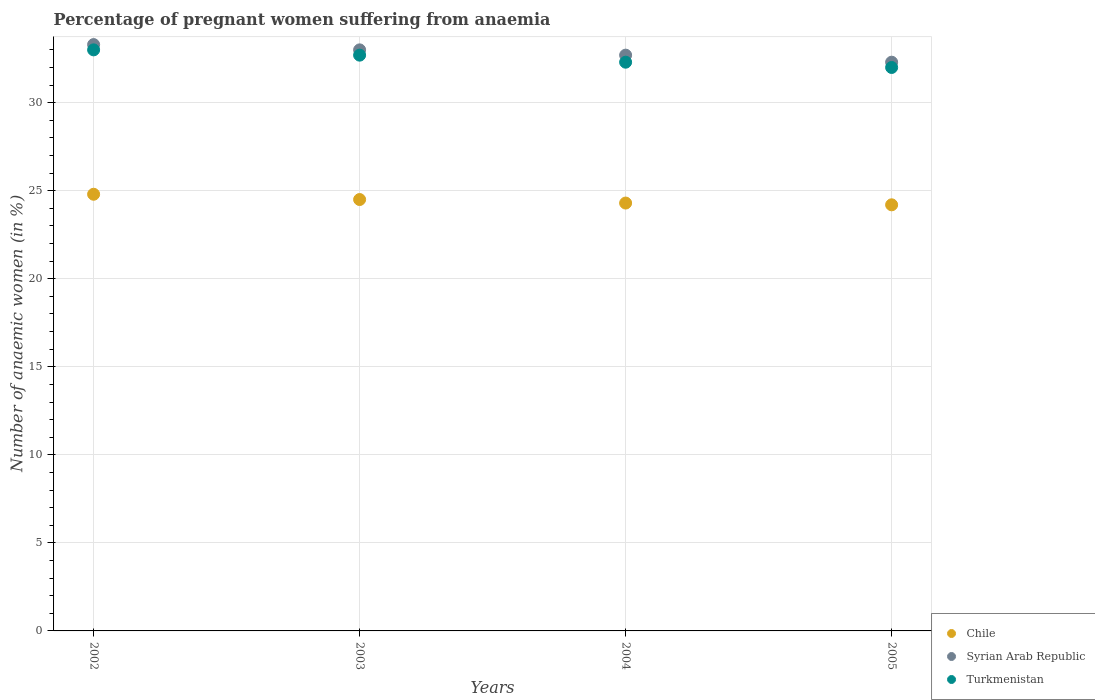What is the number of anaemic women in Turkmenistan in 2002?
Keep it short and to the point. 33. Across all years, what is the maximum number of anaemic women in Chile?
Keep it short and to the point. 24.8. Across all years, what is the minimum number of anaemic women in Syrian Arab Republic?
Provide a succinct answer. 32.3. In which year was the number of anaemic women in Chile maximum?
Provide a succinct answer. 2002. What is the total number of anaemic women in Syrian Arab Republic in the graph?
Provide a short and direct response. 131.3. What is the difference between the number of anaemic women in Chile in 2004 and that in 2005?
Keep it short and to the point. 0.1. What is the difference between the number of anaemic women in Turkmenistan in 2004 and the number of anaemic women in Chile in 2002?
Make the answer very short. 7.5. What is the average number of anaemic women in Turkmenistan per year?
Offer a very short reply. 32.5. In the year 2005, what is the difference between the number of anaemic women in Chile and number of anaemic women in Turkmenistan?
Offer a terse response. -7.8. In how many years, is the number of anaemic women in Chile greater than 27 %?
Provide a short and direct response. 0. What is the ratio of the number of anaemic women in Turkmenistan in 2002 to that in 2005?
Your answer should be compact. 1.03. Is the number of anaemic women in Chile in 2003 less than that in 2005?
Offer a terse response. No. Is the difference between the number of anaemic women in Chile in 2002 and 2004 greater than the difference between the number of anaemic women in Turkmenistan in 2002 and 2004?
Offer a terse response. No. What is the difference between the highest and the second highest number of anaemic women in Chile?
Your response must be concise. 0.3. Is the sum of the number of anaemic women in Turkmenistan in 2002 and 2003 greater than the maximum number of anaemic women in Syrian Arab Republic across all years?
Ensure brevity in your answer.  Yes. Does the number of anaemic women in Chile monotonically increase over the years?
Your response must be concise. No. How many years are there in the graph?
Make the answer very short. 4. Where does the legend appear in the graph?
Offer a very short reply. Bottom right. How are the legend labels stacked?
Ensure brevity in your answer.  Vertical. What is the title of the graph?
Give a very brief answer. Percentage of pregnant women suffering from anaemia. What is the label or title of the Y-axis?
Your response must be concise. Number of anaemic women (in %). What is the Number of anaemic women (in %) in Chile in 2002?
Your answer should be compact. 24.8. What is the Number of anaemic women (in %) in Syrian Arab Republic in 2002?
Your answer should be compact. 33.3. What is the Number of anaemic women (in %) of Turkmenistan in 2002?
Your response must be concise. 33. What is the Number of anaemic women (in %) in Syrian Arab Republic in 2003?
Make the answer very short. 33. What is the Number of anaemic women (in %) of Turkmenistan in 2003?
Keep it short and to the point. 32.7. What is the Number of anaemic women (in %) in Chile in 2004?
Your answer should be compact. 24.3. What is the Number of anaemic women (in %) in Syrian Arab Republic in 2004?
Keep it short and to the point. 32.7. What is the Number of anaemic women (in %) in Turkmenistan in 2004?
Your response must be concise. 32.3. What is the Number of anaemic women (in %) in Chile in 2005?
Offer a very short reply. 24.2. What is the Number of anaemic women (in %) of Syrian Arab Republic in 2005?
Offer a terse response. 32.3. What is the Number of anaemic women (in %) in Turkmenistan in 2005?
Provide a short and direct response. 32. Across all years, what is the maximum Number of anaemic women (in %) of Chile?
Keep it short and to the point. 24.8. Across all years, what is the maximum Number of anaemic women (in %) of Syrian Arab Republic?
Offer a terse response. 33.3. Across all years, what is the minimum Number of anaemic women (in %) in Chile?
Offer a terse response. 24.2. Across all years, what is the minimum Number of anaemic women (in %) of Syrian Arab Republic?
Make the answer very short. 32.3. What is the total Number of anaemic women (in %) in Chile in the graph?
Provide a succinct answer. 97.8. What is the total Number of anaemic women (in %) in Syrian Arab Republic in the graph?
Provide a succinct answer. 131.3. What is the total Number of anaemic women (in %) in Turkmenistan in the graph?
Your answer should be very brief. 130. What is the difference between the Number of anaemic women (in %) in Turkmenistan in 2002 and that in 2003?
Your response must be concise. 0.3. What is the difference between the Number of anaemic women (in %) in Chile in 2002 and that in 2004?
Make the answer very short. 0.5. What is the difference between the Number of anaemic women (in %) in Turkmenistan in 2002 and that in 2004?
Give a very brief answer. 0.7. What is the difference between the Number of anaemic women (in %) in Chile in 2002 and that in 2005?
Offer a very short reply. 0.6. What is the difference between the Number of anaemic women (in %) of Syrian Arab Republic in 2002 and that in 2005?
Your answer should be very brief. 1. What is the difference between the Number of anaemic women (in %) of Chile in 2003 and that in 2004?
Give a very brief answer. 0.2. What is the difference between the Number of anaemic women (in %) of Turkmenistan in 2003 and that in 2004?
Make the answer very short. 0.4. What is the difference between the Number of anaemic women (in %) of Syrian Arab Republic in 2003 and that in 2005?
Offer a very short reply. 0.7. What is the difference between the Number of anaemic women (in %) in Turkmenistan in 2003 and that in 2005?
Provide a short and direct response. 0.7. What is the difference between the Number of anaemic women (in %) in Chile in 2004 and that in 2005?
Keep it short and to the point. 0.1. What is the difference between the Number of anaemic women (in %) in Syrian Arab Republic in 2004 and that in 2005?
Offer a terse response. 0.4. What is the difference between the Number of anaemic women (in %) of Turkmenistan in 2004 and that in 2005?
Ensure brevity in your answer.  0.3. What is the difference between the Number of anaemic women (in %) of Chile in 2002 and the Number of anaemic women (in %) of Turkmenistan in 2003?
Your response must be concise. -7.9. What is the difference between the Number of anaemic women (in %) of Syrian Arab Republic in 2002 and the Number of anaemic women (in %) of Turkmenistan in 2003?
Give a very brief answer. 0.6. What is the difference between the Number of anaemic women (in %) in Chile in 2002 and the Number of anaemic women (in %) in Turkmenistan in 2004?
Provide a short and direct response. -7.5. What is the difference between the Number of anaemic women (in %) of Syrian Arab Republic in 2002 and the Number of anaemic women (in %) of Turkmenistan in 2004?
Your response must be concise. 1. What is the difference between the Number of anaemic women (in %) in Chile in 2002 and the Number of anaemic women (in %) in Turkmenistan in 2005?
Ensure brevity in your answer.  -7.2. What is the difference between the Number of anaemic women (in %) of Chile in 2004 and the Number of anaemic women (in %) of Syrian Arab Republic in 2005?
Make the answer very short. -8. What is the difference between the Number of anaemic women (in %) of Chile in 2004 and the Number of anaemic women (in %) of Turkmenistan in 2005?
Keep it short and to the point. -7.7. What is the average Number of anaemic women (in %) in Chile per year?
Your answer should be compact. 24.45. What is the average Number of anaemic women (in %) in Syrian Arab Republic per year?
Provide a succinct answer. 32.83. What is the average Number of anaemic women (in %) of Turkmenistan per year?
Provide a short and direct response. 32.5. In the year 2002, what is the difference between the Number of anaemic women (in %) of Chile and Number of anaemic women (in %) of Syrian Arab Republic?
Your response must be concise. -8.5. In the year 2003, what is the difference between the Number of anaemic women (in %) of Chile and Number of anaemic women (in %) of Syrian Arab Republic?
Provide a succinct answer. -8.5. In the year 2003, what is the difference between the Number of anaemic women (in %) in Chile and Number of anaemic women (in %) in Turkmenistan?
Your answer should be very brief. -8.2. In the year 2003, what is the difference between the Number of anaemic women (in %) of Syrian Arab Republic and Number of anaemic women (in %) of Turkmenistan?
Make the answer very short. 0.3. In the year 2004, what is the difference between the Number of anaemic women (in %) in Chile and Number of anaemic women (in %) in Turkmenistan?
Offer a terse response. -8. In the year 2004, what is the difference between the Number of anaemic women (in %) of Syrian Arab Republic and Number of anaemic women (in %) of Turkmenistan?
Your response must be concise. 0.4. In the year 2005, what is the difference between the Number of anaemic women (in %) of Syrian Arab Republic and Number of anaemic women (in %) of Turkmenistan?
Provide a succinct answer. 0.3. What is the ratio of the Number of anaemic women (in %) in Chile in 2002 to that in 2003?
Offer a terse response. 1.01. What is the ratio of the Number of anaemic women (in %) in Syrian Arab Republic in 2002 to that in 2003?
Your response must be concise. 1.01. What is the ratio of the Number of anaemic women (in %) of Turkmenistan in 2002 to that in 2003?
Offer a very short reply. 1.01. What is the ratio of the Number of anaemic women (in %) of Chile in 2002 to that in 2004?
Your response must be concise. 1.02. What is the ratio of the Number of anaemic women (in %) in Syrian Arab Republic in 2002 to that in 2004?
Make the answer very short. 1.02. What is the ratio of the Number of anaemic women (in %) in Turkmenistan in 2002 to that in 2004?
Your answer should be compact. 1.02. What is the ratio of the Number of anaemic women (in %) of Chile in 2002 to that in 2005?
Offer a terse response. 1.02. What is the ratio of the Number of anaemic women (in %) of Syrian Arab Republic in 2002 to that in 2005?
Keep it short and to the point. 1.03. What is the ratio of the Number of anaemic women (in %) of Turkmenistan in 2002 to that in 2005?
Your response must be concise. 1.03. What is the ratio of the Number of anaemic women (in %) of Chile in 2003 to that in 2004?
Give a very brief answer. 1.01. What is the ratio of the Number of anaemic women (in %) in Syrian Arab Republic in 2003 to that in 2004?
Your answer should be compact. 1.01. What is the ratio of the Number of anaemic women (in %) of Turkmenistan in 2003 to that in 2004?
Provide a short and direct response. 1.01. What is the ratio of the Number of anaemic women (in %) in Chile in 2003 to that in 2005?
Offer a very short reply. 1.01. What is the ratio of the Number of anaemic women (in %) of Syrian Arab Republic in 2003 to that in 2005?
Offer a very short reply. 1.02. What is the ratio of the Number of anaemic women (in %) in Turkmenistan in 2003 to that in 2005?
Offer a terse response. 1.02. What is the ratio of the Number of anaemic women (in %) of Syrian Arab Republic in 2004 to that in 2005?
Your response must be concise. 1.01. What is the ratio of the Number of anaemic women (in %) of Turkmenistan in 2004 to that in 2005?
Give a very brief answer. 1.01. What is the difference between the highest and the second highest Number of anaemic women (in %) in Chile?
Your answer should be compact. 0.3. What is the difference between the highest and the second highest Number of anaemic women (in %) of Turkmenistan?
Offer a terse response. 0.3. What is the difference between the highest and the lowest Number of anaemic women (in %) in Syrian Arab Republic?
Keep it short and to the point. 1. 